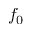<formula> <loc_0><loc_0><loc_500><loc_500>f _ { 0 }</formula> 